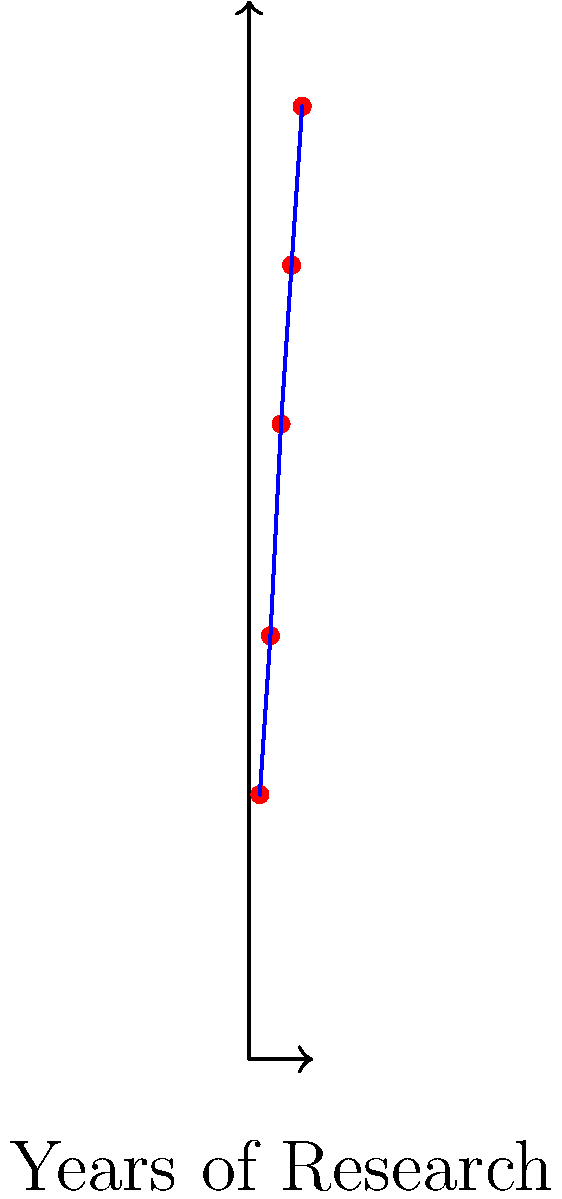Based on the infographic showing the potential applications of embryonic stem cells in treating various diseases over time, which disease is projected to have the most advanced treatment options after 5 years of research? To answer this question, we need to analyze the infographic step-by-step:

1. The x-axis represents "Years of Research" from 1 to 5 years.
2. The y-axis represents "Potential Applications" on a scale from 0 to 100.
3. Each point on the graph represents a different disease and its potential for treatment using embryonic stem cells over time.
4. The diseases shown are:
   - Parkinson's (Year 1, lowest on the scale)
   - Alzheimer's (Year 2)
   - Diabetes (Year 3)
   - Heart Disease (Year 4)
   - Cancer (Year 5, highest on the scale)

5. The graph shows an increasing trend, indicating that as research progresses, the potential applications for stem cell treatments increase for all diseases.

6. At the 5-year mark, Cancer is positioned at the top of the graph, indicating the highest potential for treatment applications using embryonic stem cells.

Therefore, according to this infographic, Cancer is projected to have the most advanced treatment options after 5 years of embryonic stem cell research.
Answer: Cancer 